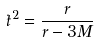<formula> <loc_0><loc_0><loc_500><loc_500>\dot { t } ^ { 2 } = \frac { r } { r - 3 M }</formula> 